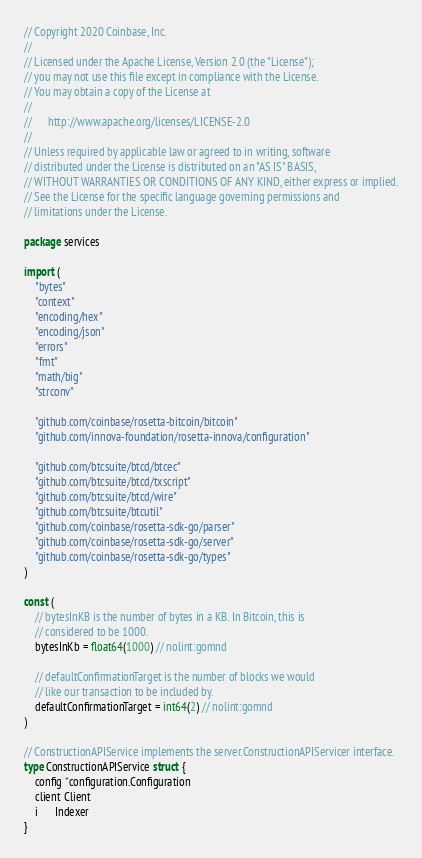<code> <loc_0><loc_0><loc_500><loc_500><_Go_>// Copyright 2020 Coinbase, Inc.
//
// Licensed under the Apache License, Version 2.0 (the "License");
// you may not use this file except in compliance with the License.
// You may obtain a copy of the License at
//
//      http://www.apache.org/licenses/LICENSE-2.0
//
// Unless required by applicable law or agreed to in writing, software
// distributed under the License is distributed on an "AS IS" BASIS,
// WITHOUT WARRANTIES OR CONDITIONS OF ANY KIND, either express or implied.
// See the License for the specific language governing permissions and
// limitations under the License.

package services

import (
	"bytes"
	"context"
	"encoding/hex"
	"encoding/json"
	"errors"
	"fmt"
	"math/big"
	"strconv"

	"github.com/coinbase/rosetta-bitcoin/bitcoin"
	"github.com/innova-foundation/rosetta-innova/configuration"

	"github.com/btcsuite/btcd/btcec"
	"github.com/btcsuite/btcd/txscript"
	"github.com/btcsuite/btcd/wire"
	"github.com/btcsuite/btcutil"
	"github.com/coinbase/rosetta-sdk-go/parser"
	"github.com/coinbase/rosetta-sdk-go/server"
	"github.com/coinbase/rosetta-sdk-go/types"
)

const (
	// bytesInKB is the number of bytes in a KB. In Bitcoin, this is
	// considered to be 1000.
	bytesInKb = float64(1000) // nolint:gomnd

	// defaultConfirmationTarget is the number of blocks we would
	// like our transaction to be included by.
	defaultConfirmationTarget = int64(2) // nolint:gomnd
)

// ConstructionAPIService implements the server.ConstructionAPIServicer interface.
type ConstructionAPIService struct {
	config *configuration.Configuration
	client Client
	i      Indexer
}
</code> 